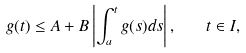<formula> <loc_0><loc_0><loc_500><loc_500>g ( t ) \leq A + B \left | \int _ { a } ^ { t } g ( s ) d s \right | , \quad t \in I ,</formula> 